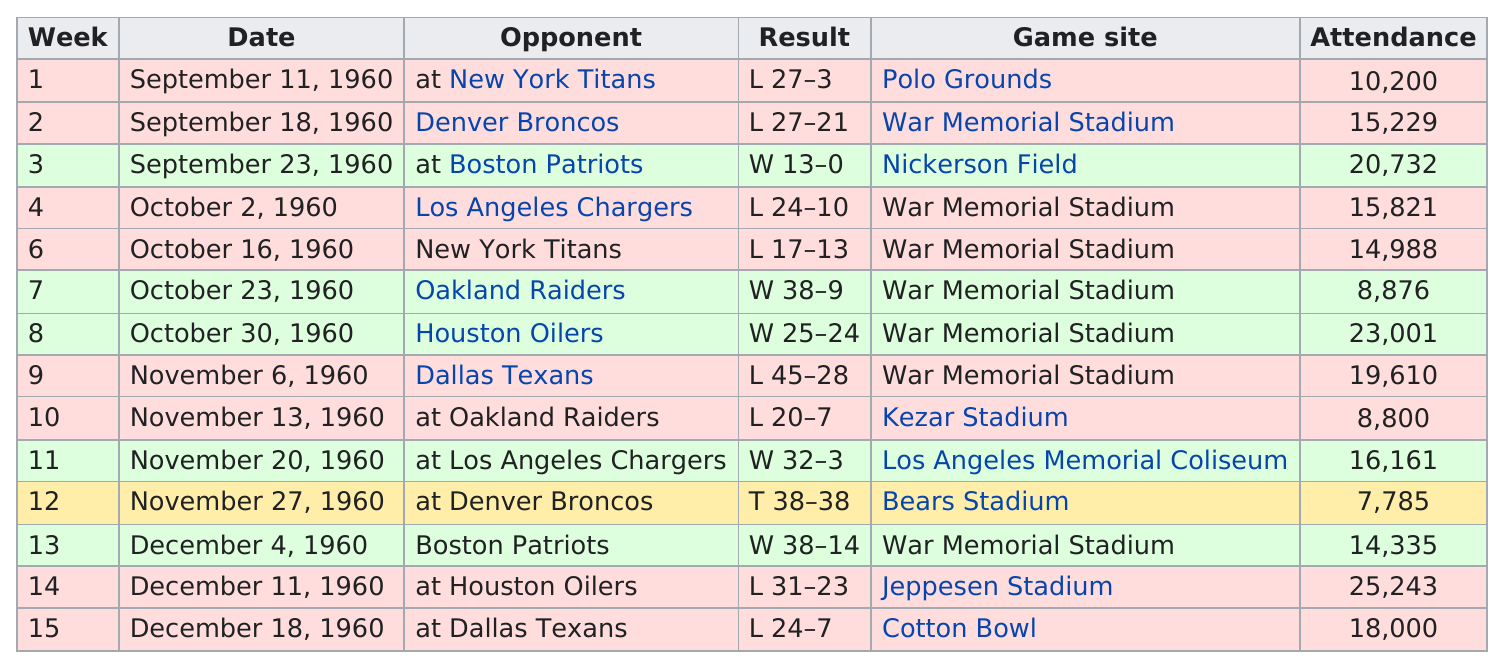Identify some key points in this picture. The only opponent they played that resulted in a tie game was the Denver Broncos. After the Oakland Raiders, the Houston Oilers played against their opponent. On December 11, 1960, the date with the highest attendance was recorded. Out of the total number of games, how many had an attendance of at least 10,000 people? The largest difference of points in a single game was 29 points. 